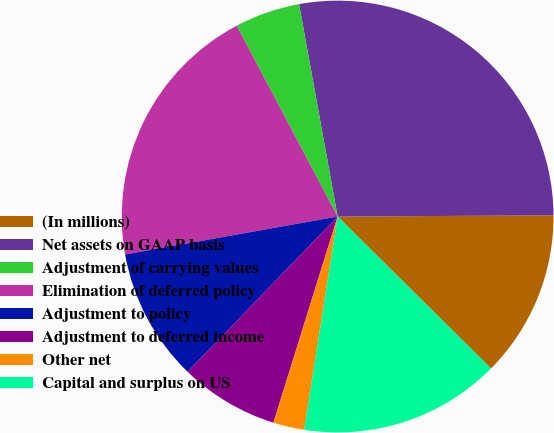Convert chart. <chart><loc_0><loc_0><loc_500><loc_500><pie_chart><fcel>(In millions)<fcel>Net assets on GAAP basis<fcel>Adjustment of carrying values<fcel>Elimination of deferred policy<fcel>Adjustment to policy<fcel>Adjustment to deferred income<fcel>Other net<fcel>Capital and surplus on US<nl><fcel>12.51%<fcel>27.77%<fcel>4.88%<fcel>20.07%<fcel>9.96%<fcel>7.42%<fcel>2.33%<fcel>15.05%<nl></chart> 